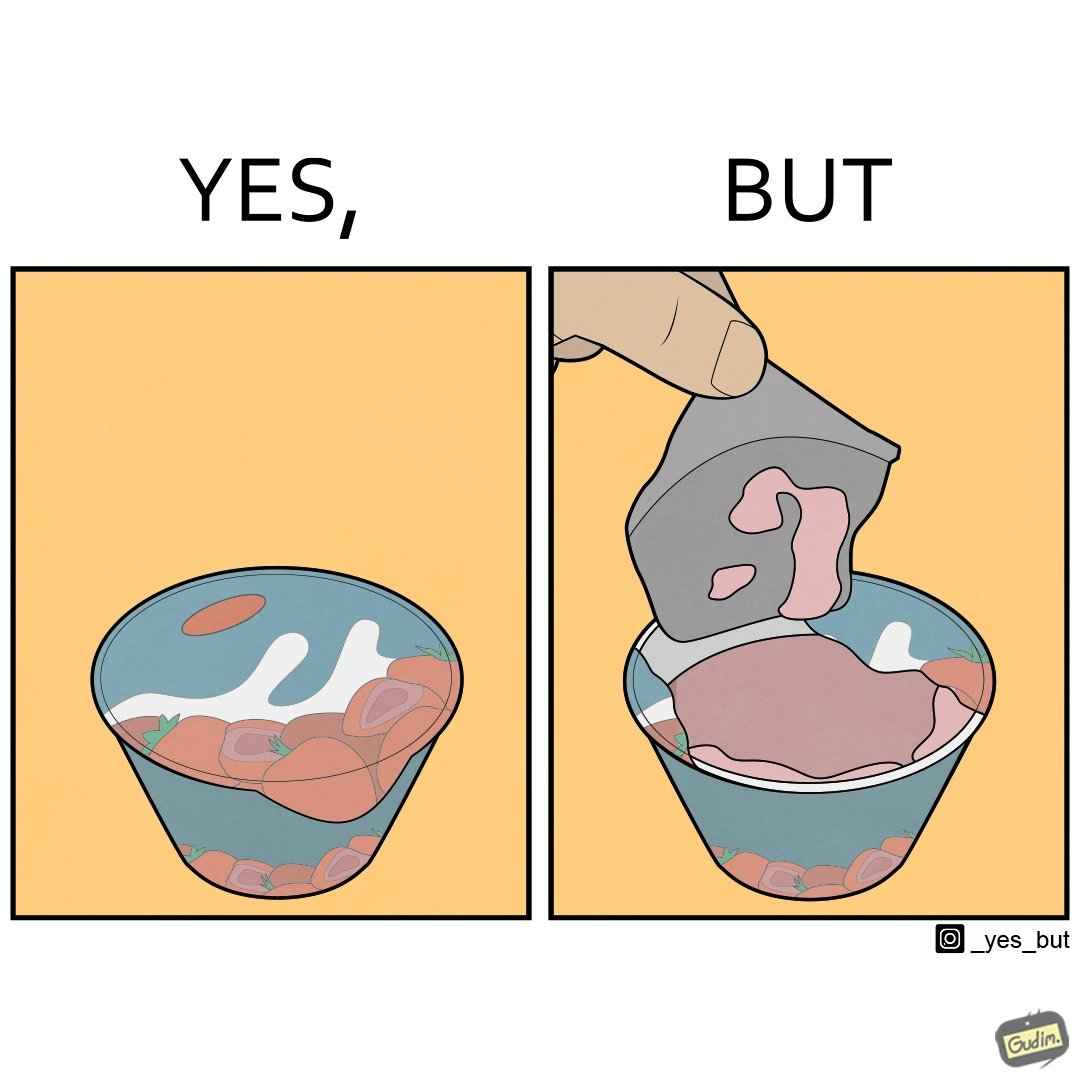What makes this image funny or satirical? The images are funny since it shows how the food packaging sets unreal expectations for the food inside with its graphics. The user gets to see the rather dull food once he opens the package and it is amusing to see how different the actual product is from the images 